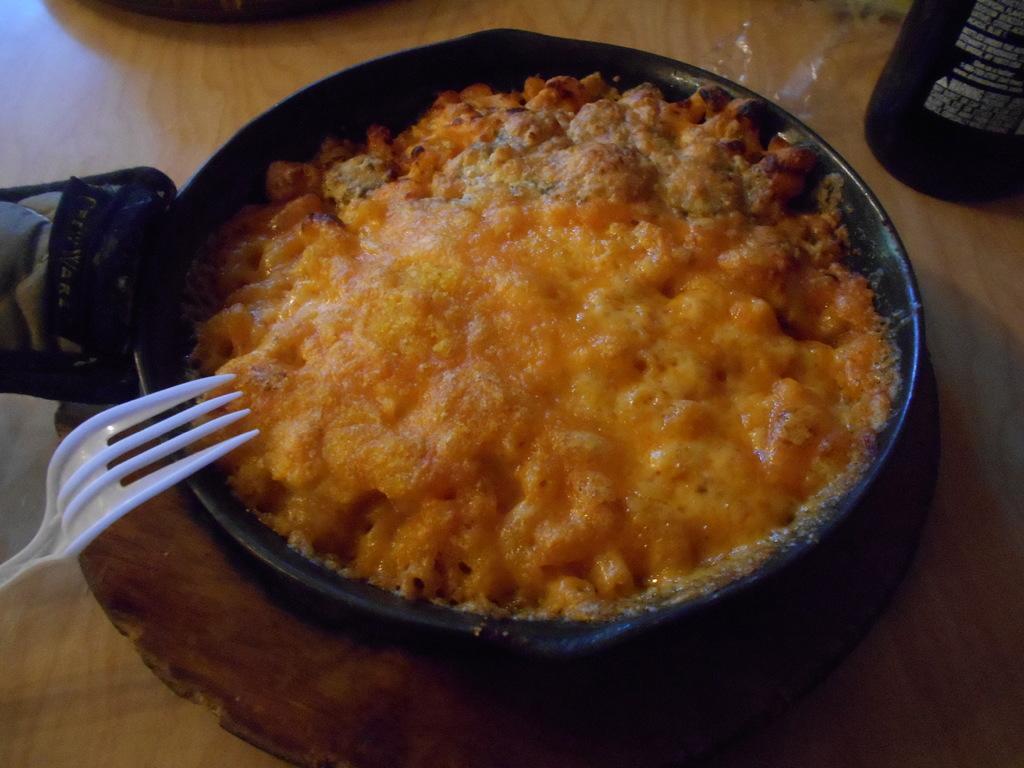In one or two sentences, can you explain what this image depicts? Here I can see a pan which consists of some food item. This is placed on a table. On the left side there is a fork. In the top right-hand corner there is a bottle. 